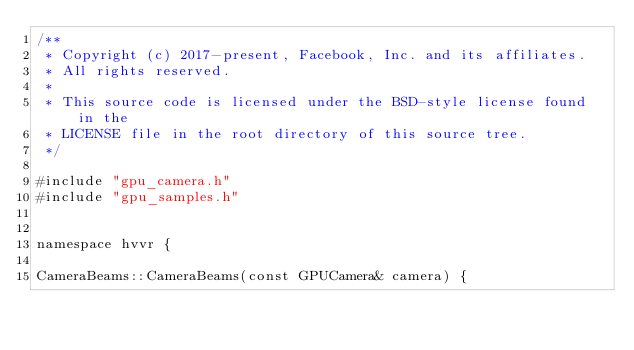<code> <loc_0><loc_0><loc_500><loc_500><_Cuda_>/**
 * Copyright (c) 2017-present, Facebook, Inc. and its affiliates.
 * All rights reserved.
 *
 * This source code is licensed under the BSD-style license found in the
 * LICENSE file in the root directory of this source tree.
 */

#include "gpu_camera.h"
#include "gpu_samples.h"


namespace hvvr {

CameraBeams::CameraBeams(const GPUCamera& camera) {</code> 